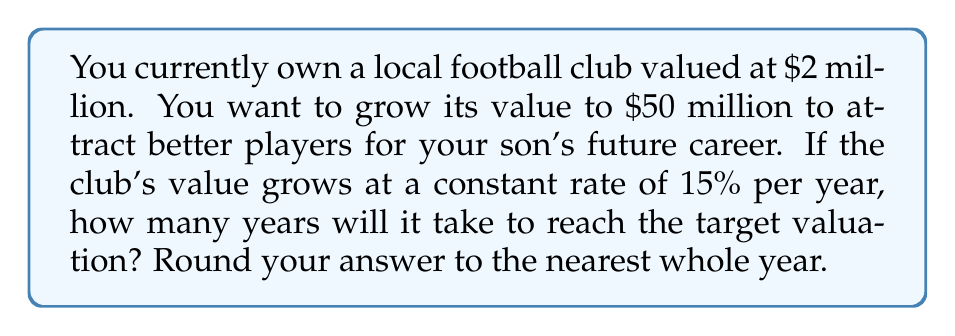Help me with this question. Let's approach this step-by-step using logarithmic equations:

1) Let $P$ be the initial value ($2 million), $A$ be the target value ($50 million), $r$ be the growth rate (15% = 0.15), and $t$ be the time in years.

2) The equation for compound growth is:
   $A = P(1+r)^t$

3) Substituting our values:
   $50 = 2(1+0.15)^t$

4) Divide both sides by 2:
   $25 = (1.15)^t$

5) Take the natural logarithm of both sides:
   $\ln(25) = t \cdot \ln(1.15)$

6) Solve for $t$:
   $t = \frac{\ln(25)}{\ln(1.15)}$

7) Calculate:
   $t = \frac{3.2189}{0.1398} \approx 23.0250$

8) Rounding to the nearest whole year:
   $t \approx 23$ years
Answer: 23 years 